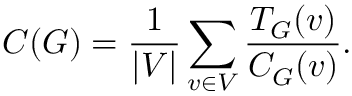<formula> <loc_0><loc_0><loc_500><loc_500>C ( G ) = \frac { 1 } { | V | } \sum _ { v \in V } \frac { T _ { G } ( v ) } { C _ { G } ( v ) } .</formula> 